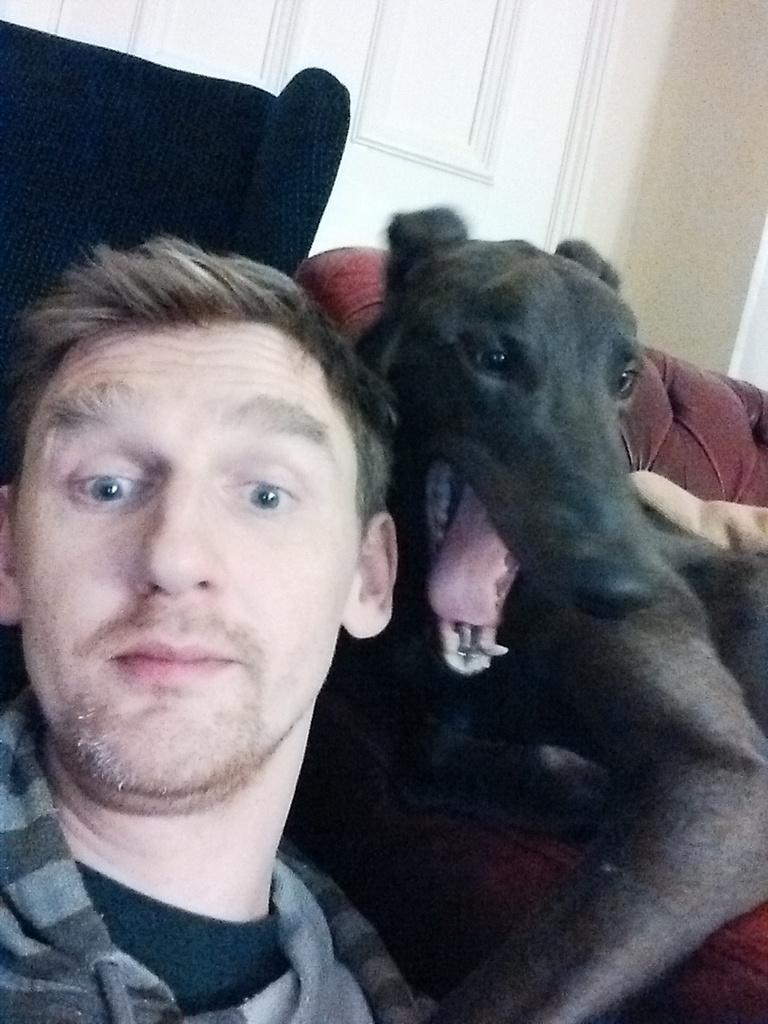Who is present in the image? There is a man and a dog in the image. What are the positions of the man and the dog in the image? The man is sitting, and the dog is sitting. What is the man wearing in the image? The man is wearing a black and grey shirt. What can be seen in the background of the image? There is a wall and a door in the background of the image. What type of statement is the monkey making in the image? There is no monkey present in the image, so it is not possible to answer that question. 